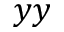Convert formula to latex. <formula><loc_0><loc_0><loc_500><loc_500>y y</formula> 